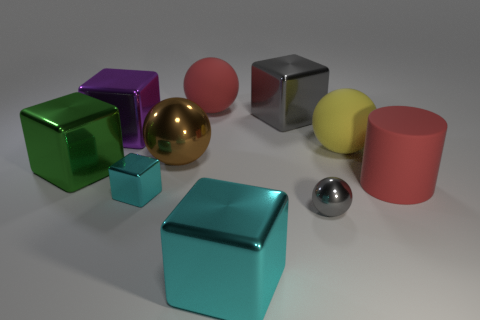There is a small object that is to the right of the big brown sphere; does it have the same color as the large shiny thing in front of the small block?
Provide a succinct answer. No. There is a gray block; how many red matte things are left of it?
Give a very brief answer. 1. There is a big thing that is the same color as the small shiny block; what material is it?
Provide a succinct answer. Metal. Is there a red object that has the same shape as the large brown shiny thing?
Provide a short and direct response. Yes. Do the big red thing that is to the right of the big gray cube and the tiny thing that is to the left of the big gray metallic object have the same material?
Offer a terse response. No. There is a red thing in front of the red matte thing that is on the left side of the metallic ball that is right of the big red sphere; what is its size?
Give a very brief answer. Large. There is a red cylinder that is the same size as the green object; what is it made of?
Give a very brief answer. Rubber. Is there another matte object of the same size as the green object?
Your response must be concise. Yes. Do the yellow thing and the brown metal object have the same shape?
Ensure brevity in your answer.  Yes. Are there any big gray things that are in front of the large metallic block in front of the tiny metallic object to the right of the tiny shiny cube?
Provide a short and direct response. No. 